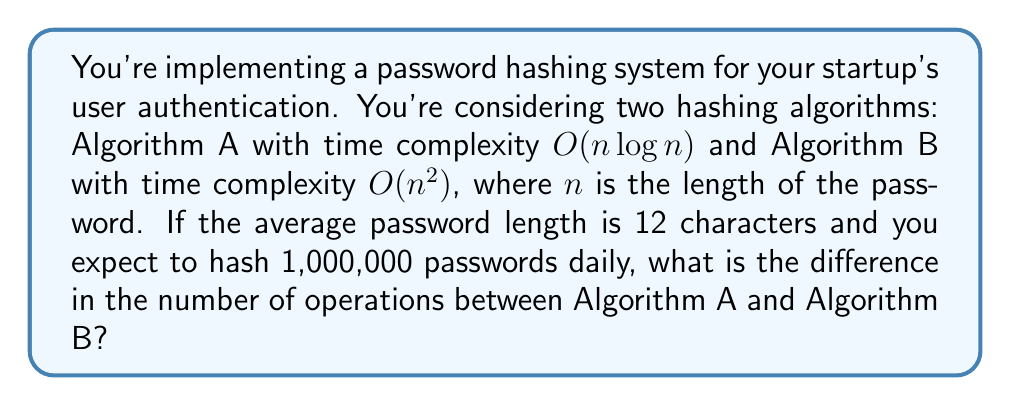Provide a solution to this math problem. Let's approach this step-by-step:

1) First, we need to calculate the number of operations for each algorithm:

   For Algorithm A: $O(n \log n)$
   For Algorithm B: $O(n^2)$

2) Given $n = 12$ (average password length):

   Algorithm A: $12 \log 12 \approx 12 * 3.58 = 42.96$ operations per password
   Algorithm B: $12^2 = 144$ operations per password

3) Now, let's calculate the total number of operations for 1,000,000 passwords:

   Algorithm A: $42.96 * 1,000,000 = 42,960,000$ operations
   Algorithm B: $144 * 1,000,000 = 144,000,000$ operations

4) To find the difference, we subtract:

   $144,000,000 - 42,960,000 = 101,040,000$

Therefore, Algorithm B performs 101,040,000 more operations than Algorithm A for the given scenario.
Answer: 101,040,000 operations 